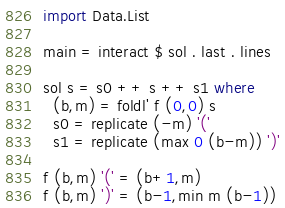Convert code to text. <code><loc_0><loc_0><loc_500><loc_500><_Haskell_>import Data.List

main = interact $ sol . last . lines

sol s = s0 ++ s ++ s1 where
  (b,m) = foldl' f (0,0) s
  s0 = replicate (-m) '('
  s1 = replicate (max 0 (b-m)) ')'

f (b,m) '(' = (b+1,m)
f (b,m) ')' = (b-1,min m (b-1))</code> 